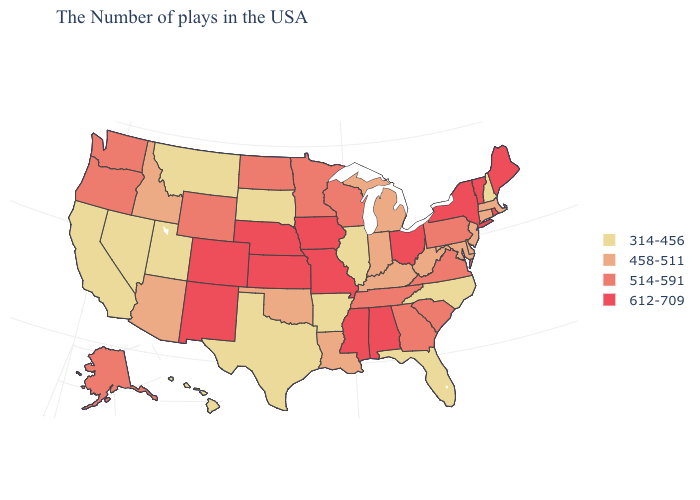Which states hav the highest value in the West?
Answer briefly. Colorado, New Mexico. What is the value of California?
Keep it brief. 314-456. Among the states that border Tennessee , which have the highest value?
Answer briefly. Alabama, Mississippi, Missouri. Does Oregon have the lowest value in the West?
Keep it brief. No. Does Louisiana have a lower value than Oregon?
Give a very brief answer. Yes. What is the value of Illinois?
Concise answer only. 314-456. Which states have the lowest value in the West?
Short answer required. Utah, Montana, Nevada, California, Hawaii. How many symbols are there in the legend?
Write a very short answer. 4. What is the value of Missouri?
Be succinct. 612-709. Name the states that have a value in the range 458-511?
Give a very brief answer. Massachusetts, Connecticut, New Jersey, Delaware, Maryland, West Virginia, Michigan, Kentucky, Indiana, Louisiana, Oklahoma, Arizona, Idaho. Which states have the lowest value in the USA?
Concise answer only. New Hampshire, North Carolina, Florida, Illinois, Arkansas, Texas, South Dakota, Utah, Montana, Nevada, California, Hawaii. What is the highest value in the USA?
Keep it brief. 612-709. Name the states that have a value in the range 612-709?
Write a very short answer. Maine, Rhode Island, Vermont, New York, Ohio, Alabama, Mississippi, Missouri, Iowa, Kansas, Nebraska, Colorado, New Mexico. Which states have the highest value in the USA?
Answer briefly. Maine, Rhode Island, Vermont, New York, Ohio, Alabama, Mississippi, Missouri, Iowa, Kansas, Nebraska, Colorado, New Mexico. What is the value of Maine?
Be succinct. 612-709. 